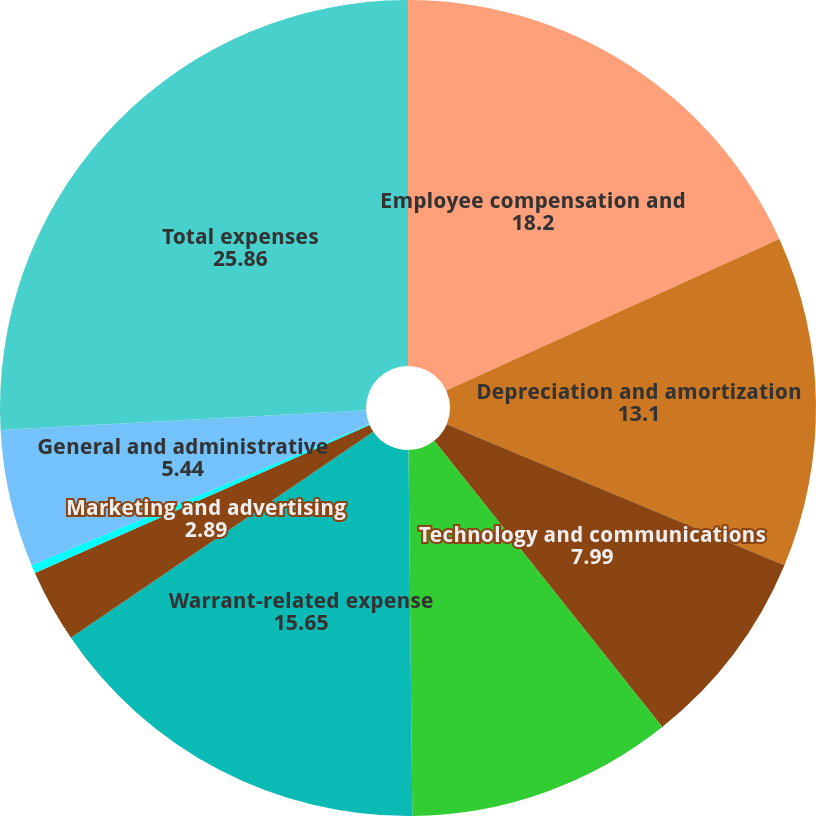<chart> <loc_0><loc_0><loc_500><loc_500><pie_chart><fcel>Employee compensation and<fcel>Depreciation and amortization<fcel>Technology and communications<fcel>Professional and consulting<fcel>Warrant-related expense<fcel>Marketing and advertising<fcel>Moneyline revenue share<fcel>General and administrative<fcel>Total expenses<nl><fcel>18.2%<fcel>13.1%<fcel>7.99%<fcel>10.54%<fcel>15.65%<fcel>2.89%<fcel>0.33%<fcel>5.44%<fcel>25.86%<nl></chart> 